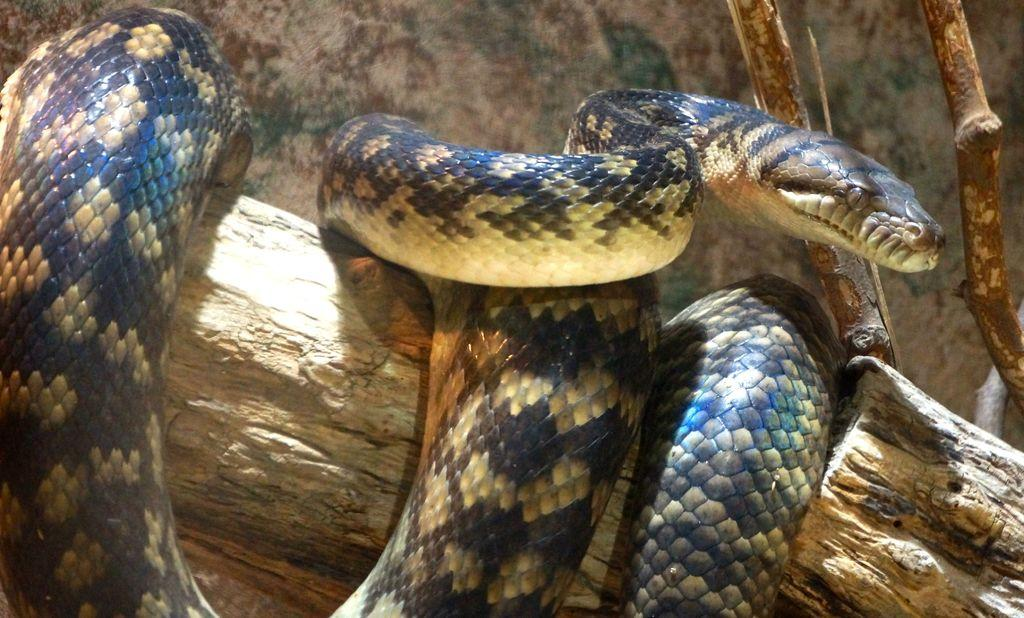What animal is present in the image? There is a snake in the image. What type of surface is the snake on? The snake is on a wooden surface. What other wooden objects can be seen in the image? There are wooden sticks in the image. What type of store can be seen in the background of the image? There is no store present in the image; it only features a snake on a wooden surface and wooden sticks. 